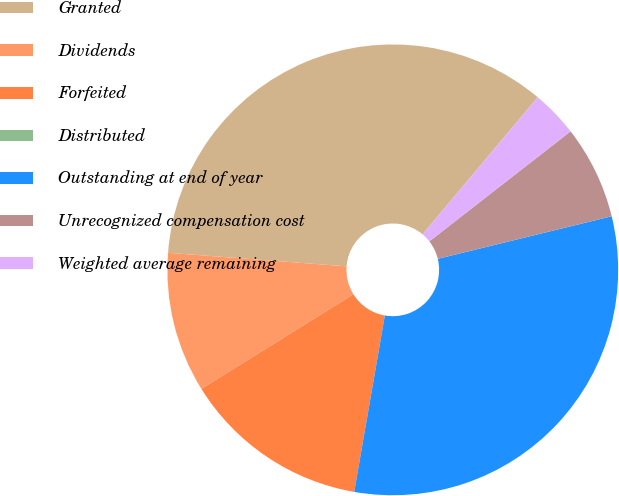<chart> <loc_0><loc_0><loc_500><loc_500><pie_chart><fcel>Granted<fcel>Dividends<fcel>Forfeited<fcel>Distributed<fcel>Outstanding at end of year<fcel>Unrecognized compensation cost<fcel>Weighted average remaining<nl><fcel>34.91%<fcel>10.06%<fcel>13.41%<fcel>0.0%<fcel>31.56%<fcel>6.71%<fcel>3.35%<nl></chart> 